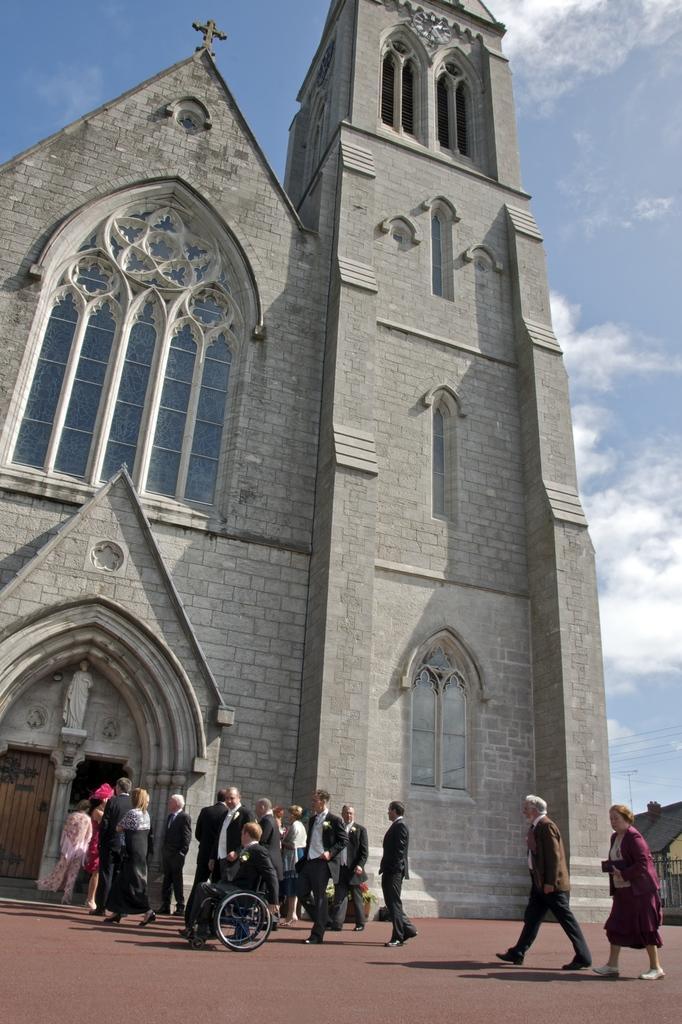Could you give a brief overview of what you see in this image? In this image, we can see a church. There are some persons at the bottom of the image. In the background of the image, there is a sky. 